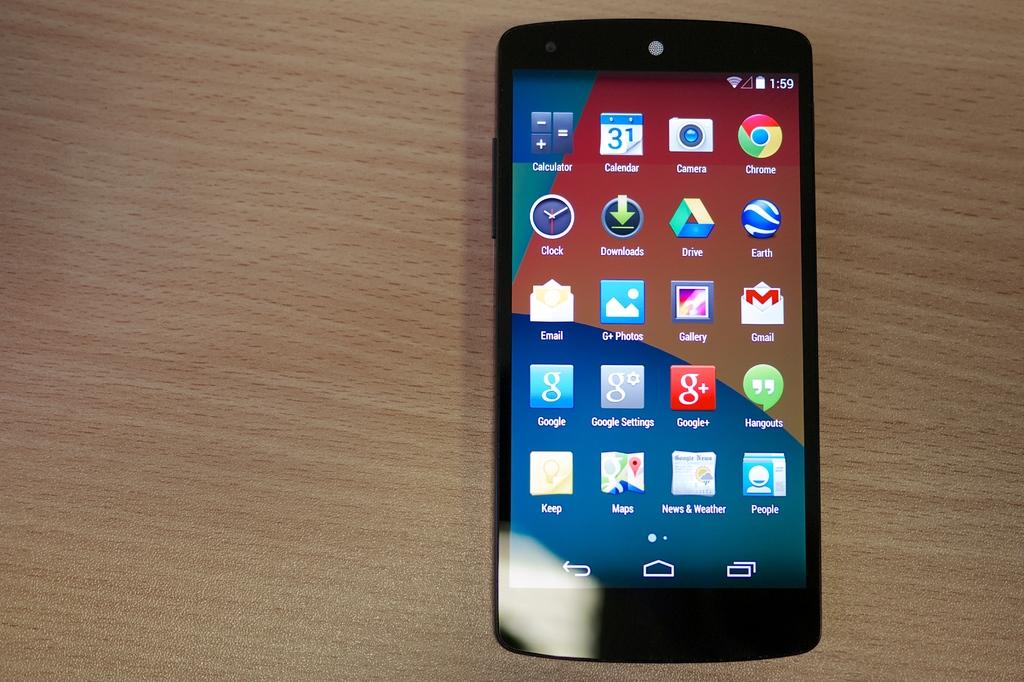What is the main object in the image? There is a mobile in the image. What type of surface is the mobile placed on? The mobile is on a wooden surface. What can be seen on the mobile's screen? There are applications on the mobile. What type of bird can be seen sitting on the mobile in the image? There is no bird, specifically a robin, present in the image. What type of musical instrument can be seen attached to the mobile in the image? There is no musical instrument, specifically a horn, present in the image. What color are the eyes of the person using the mobile in the image? There is no person using the mobile in the image, so their eye color cannot be determined. 